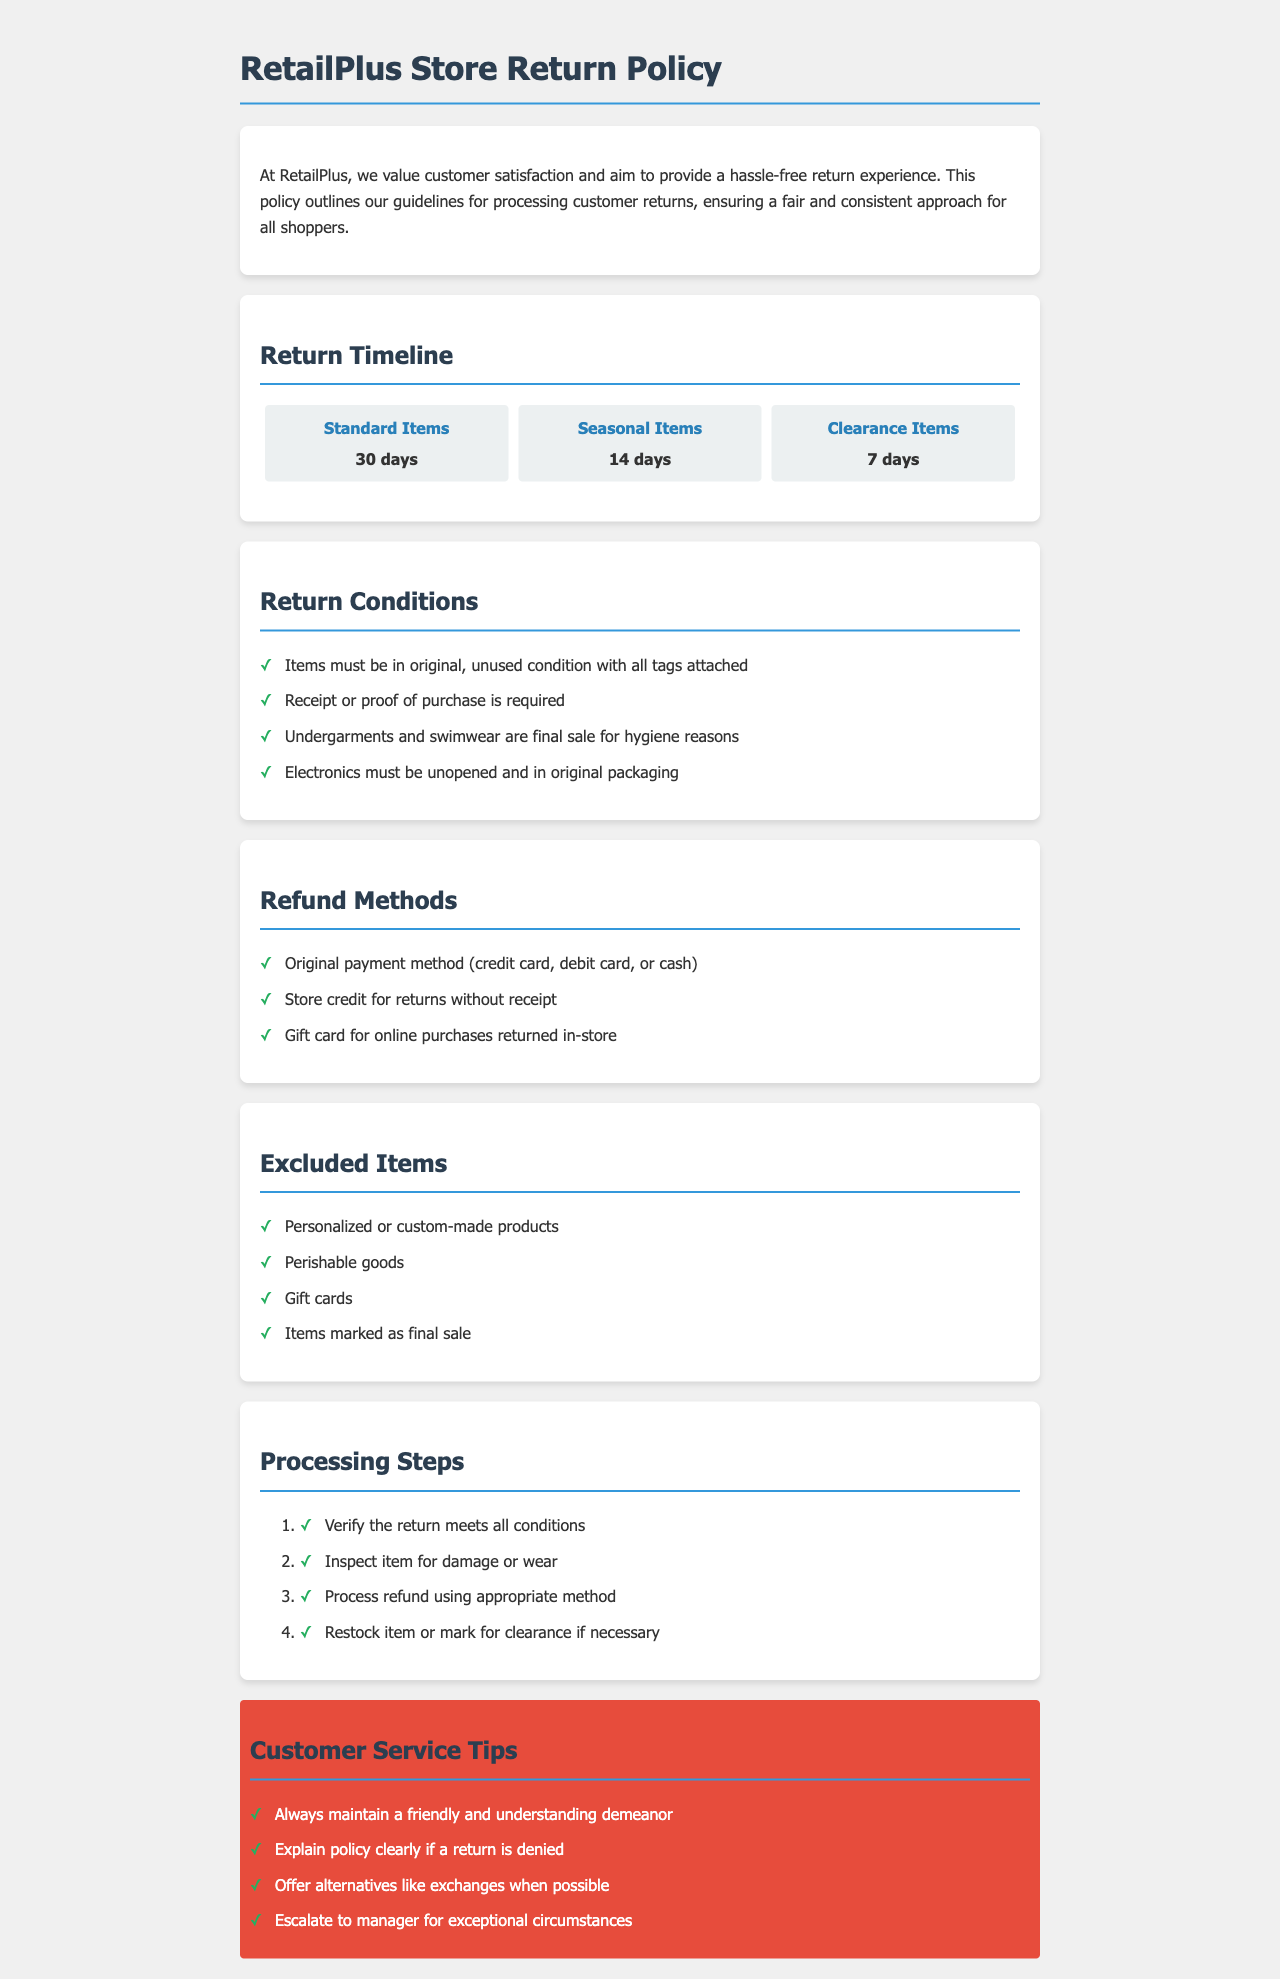What is the return period for standard items? The return period for standard items is specified in the "Return Timeline" section as 30 days.
Answer: 30 days What item types have a return period of 14 days? The return period of 14 days applies to seasonal items, as per the "Return Timeline" section.
Answer: Seasonal Items What condition must items meet for a return? The document states that items must be in original, unused condition with all tags attached as part of the return conditions.
Answer: Original, unused condition with all tags attached Which method is used for refunds without a receipt? According to the "Refund Methods" section, store credit is provided for returns without a receipt.
Answer: Store credit What are the excluded items from the return policy? The document lists several items as excluded, including personalized products, perishable goods, and gift cards.
Answer: Personalized or custom-made products What is the first step in processing a return? The processing steps outline that the first action is to verify that the return meets all conditions.
Answer: Verify the return meets all conditions How should customer service representatives handle denied returns? The policy suggests they should explain the policy clearly if a return is denied, according to the customer service tips.
Answer: Explain policy clearly What is the return period for clearance items? Clearance items must be returned within 7 days, as indicated in the "Return Timeline" section.
Answer: 7 days 